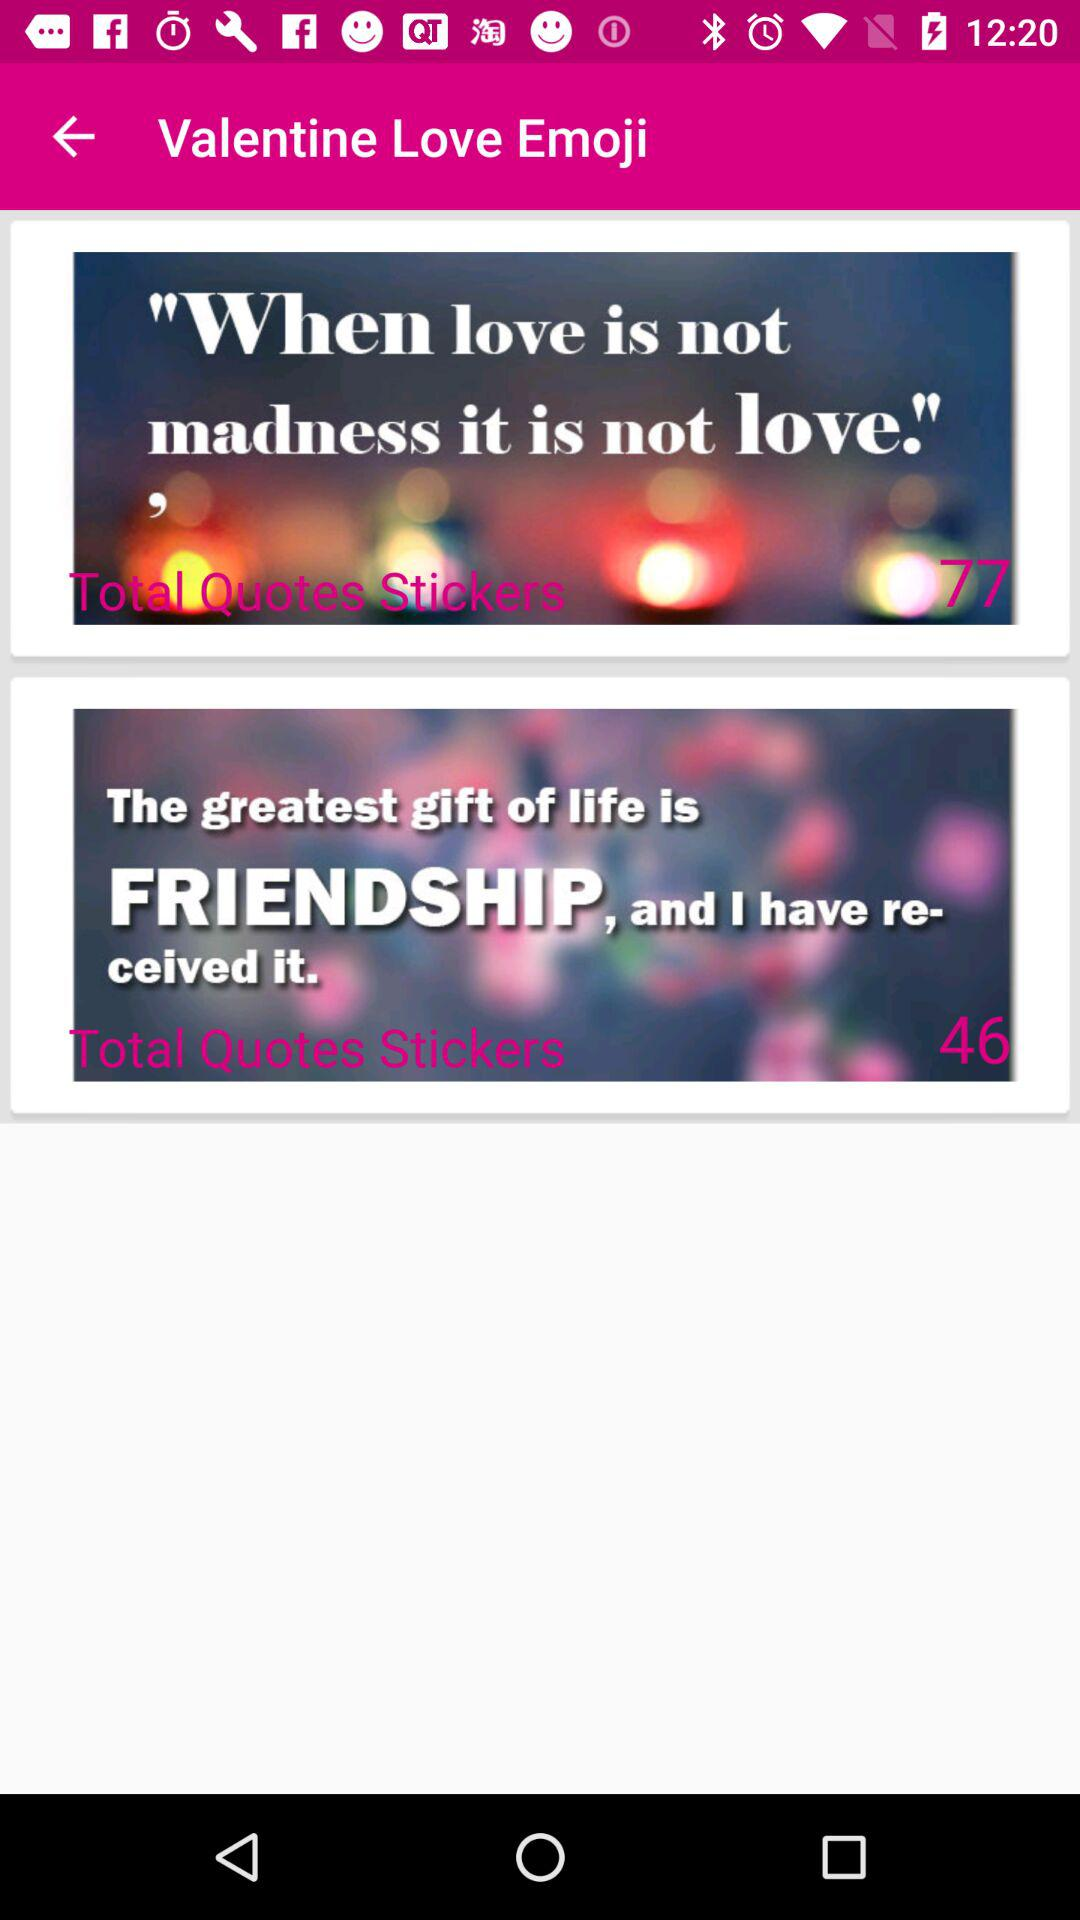What is the name of the application? The name of the application is "Valentine Love Emoji". 